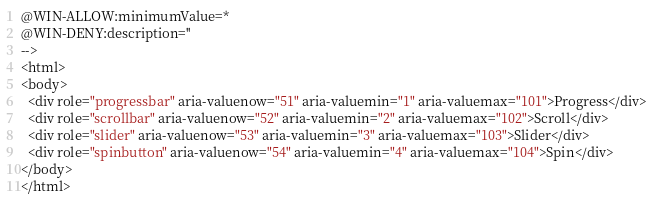<code> <loc_0><loc_0><loc_500><loc_500><_HTML_>@WIN-ALLOW:minimumValue=*
@WIN-DENY:description=''
-->
<html>
<body>
  <div role="progressbar" aria-valuenow="51" aria-valuemin="1" aria-valuemax="101">Progress</div>
  <div role="scrollbar" aria-valuenow="52" aria-valuemin="2" aria-valuemax="102">Scroll</div>
  <div role="slider" aria-valuenow="53" aria-valuemin="3" aria-valuemax="103">Slider</div>
  <div role="spinbutton" aria-valuenow="54" aria-valuemin="4" aria-valuemax="104">Spin</div>
</body>
</html>
</code> 